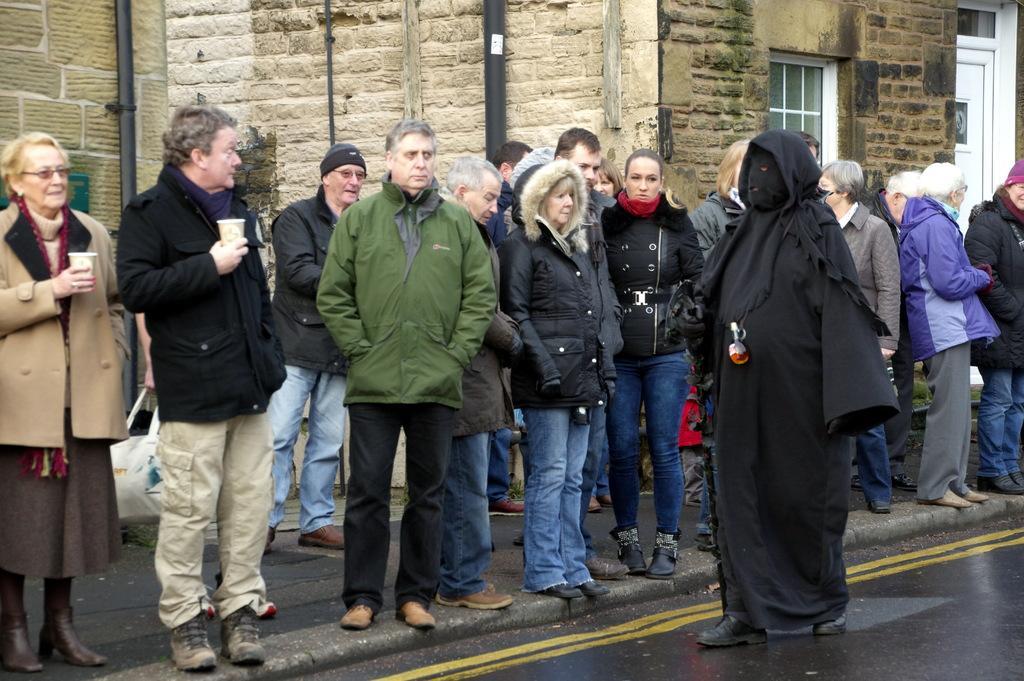How would you summarize this image in a sentence or two? In this image we can see people and there is a road. In the background we can see a building, poles, window, and a door. 